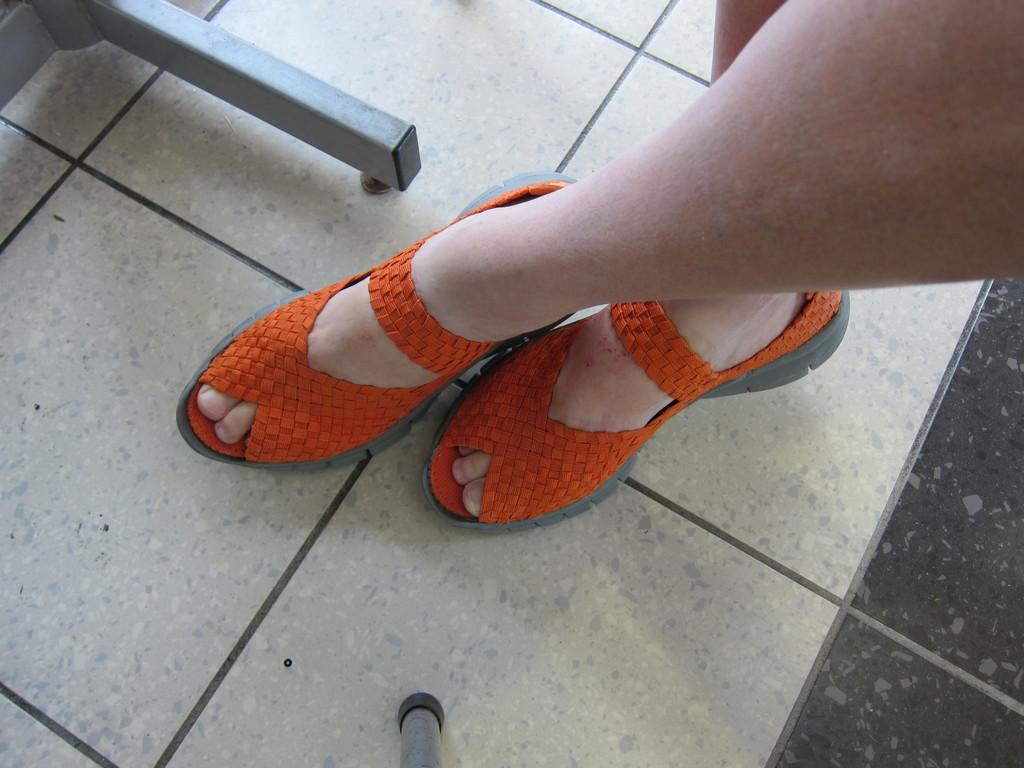Could you give a brief overview of what you see in this image? In this image we can see the legs of a person wearing shoes. In the background, we can see some metal poles placed on the floor. 